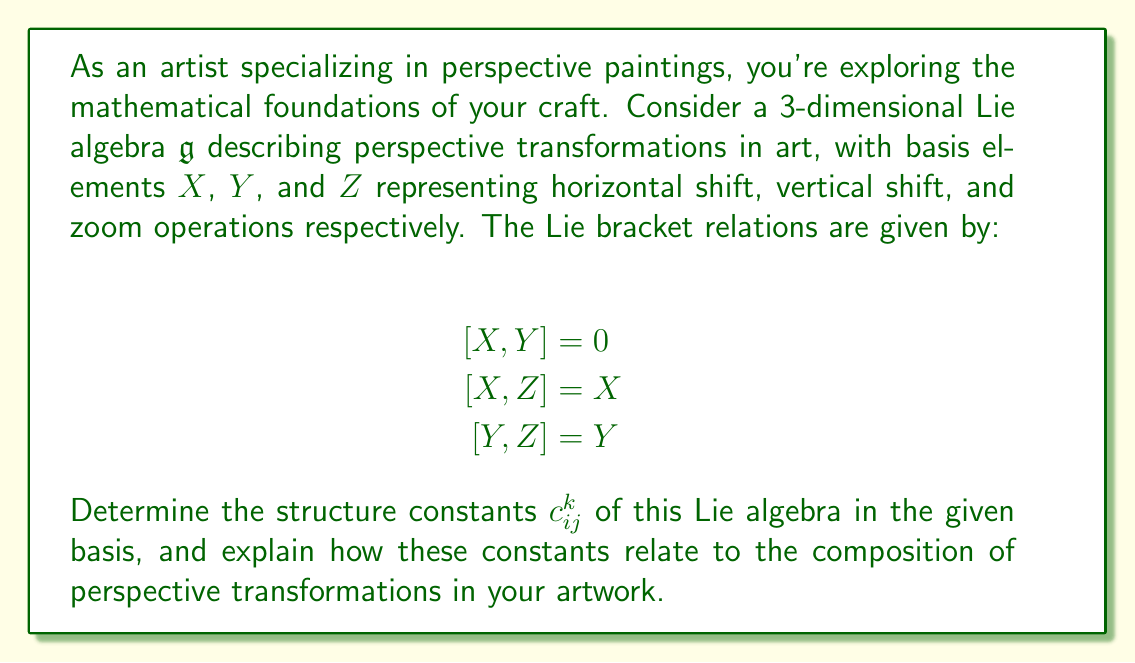Show me your answer to this math problem. To solve this problem, we'll follow these steps:

1) Recall that for a Lie algebra with basis elements $E_i$, the structure constants $c_{ij}^k$ are defined by the equation:

   $$[E_i, E_j] = \sum_k c_{ij}^k E_k$$

2) In our case, $E_1 = X$, $E_2 = Y$, and $E_3 = Z$. We need to express each Lie bracket in terms of these basis elements.

3) From the given relations:

   $[X,Y] = 0 = 0X + 0Y + 0Z$
   $[X,Z] = X = 1X + 0Y + 0Z$
   $[Y,Z] = Y = 0X + 1Y + 0Z$

4) We can also deduce that $[Y,X] = -[X,Y] = 0$, $[Z,X] = -[X,Z] = -X$, and $[Z,Y] = -[Y,Z] = -Y$ due to the antisymmetry of the Lie bracket.

5) Now, we can read off the non-zero structure constants:

   $c_{13}^1 = 1$ (from $[X,Z] = X$)
   $c_{23}^2 = 1$ (from $[Y,Z] = Y$)
   $c_{31}^1 = -1$ (from $[Z,X] = -X$)
   $c_{32}^2 = -1$ (from $[Z,Y] = -Y$)

6) All other structure constants are zero.

7) In terms of perspective transformations:
   - The relation $[X,Y] = 0$ means that horizontal and vertical shifts commute (order doesn't matter).
   - $[X,Z] = X$ and $[Y,Z] = Y$ indicate that zooming affects the magnitude of shifts, which is consistent with how perspective works in art. Zooming in makes shifts appear larger, while zooming out makes them appear smaller.

These structure constants encapsulate the fundamental relationships between different perspective transformations, providing a mathematical framework for understanding how these operations compose in your artwork.
Answer: The non-zero structure constants are:
$$c_{13}^1 = 1, \quad c_{23}^2 = 1, \quad c_{31}^1 = -1, \quad c_{32}^2 = -1$$
All other structure constants are zero. 